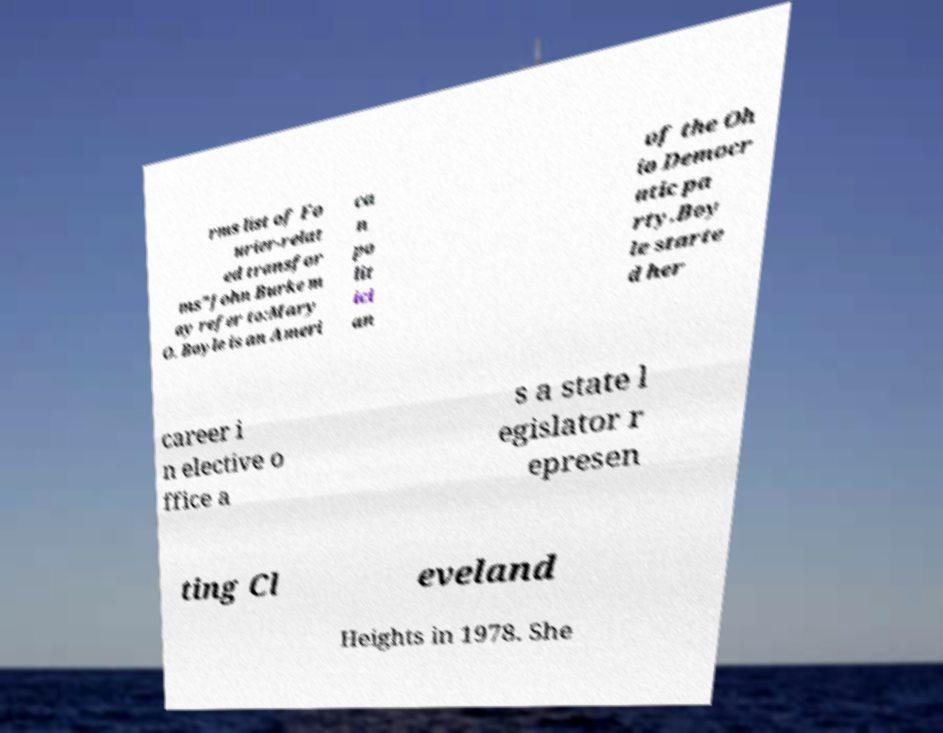Can you read and provide the text displayed in the image?This photo seems to have some interesting text. Can you extract and type it out for me? rms list of Fo urier-relat ed transfor ms"John Burke m ay refer to:Mary O. Boyle is an Ameri ca n po lit ici an of the Oh io Democr atic pa rty.Boy le starte d her career i n elective o ffice a s a state l egislator r epresen ting Cl eveland Heights in 1978. She 